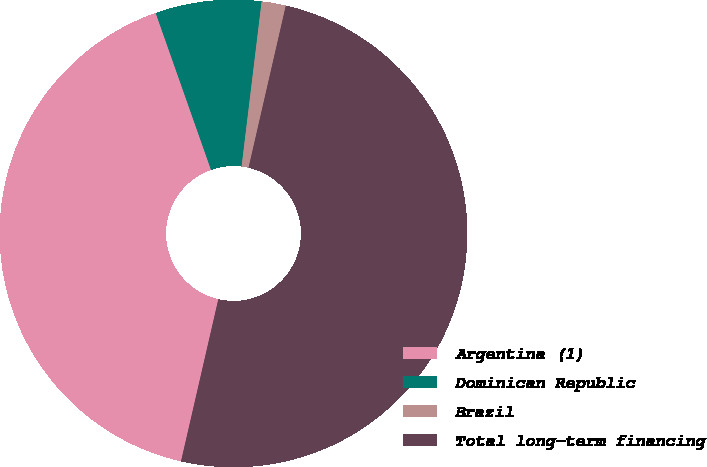Convert chart to OTSL. <chart><loc_0><loc_0><loc_500><loc_500><pie_chart><fcel>Argentina (1)<fcel>Dominican Republic<fcel>Brazil<fcel>Total long-term financing<nl><fcel>41.0%<fcel>7.32%<fcel>1.67%<fcel>50.0%<nl></chart> 